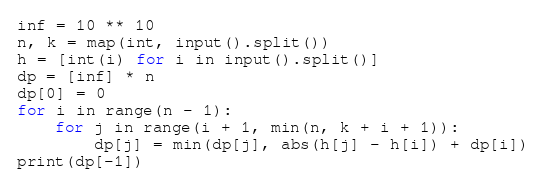Convert code to text. <code><loc_0><loc_0><loc_500><loc_500><_Python_>inf = 10 ** 10
n, k = map(int, input().split())
h = [int(i) for i in input().split()]
dp = [inf] * n
dp[0] = 0
for i in range(n - 1):
    for j in range(i + 1, min(n, k + i + 1)):
        dp[j] = min(dp[j], abs(h[j] - h[i]) + dp[i])
print(dp[-1])</code> 